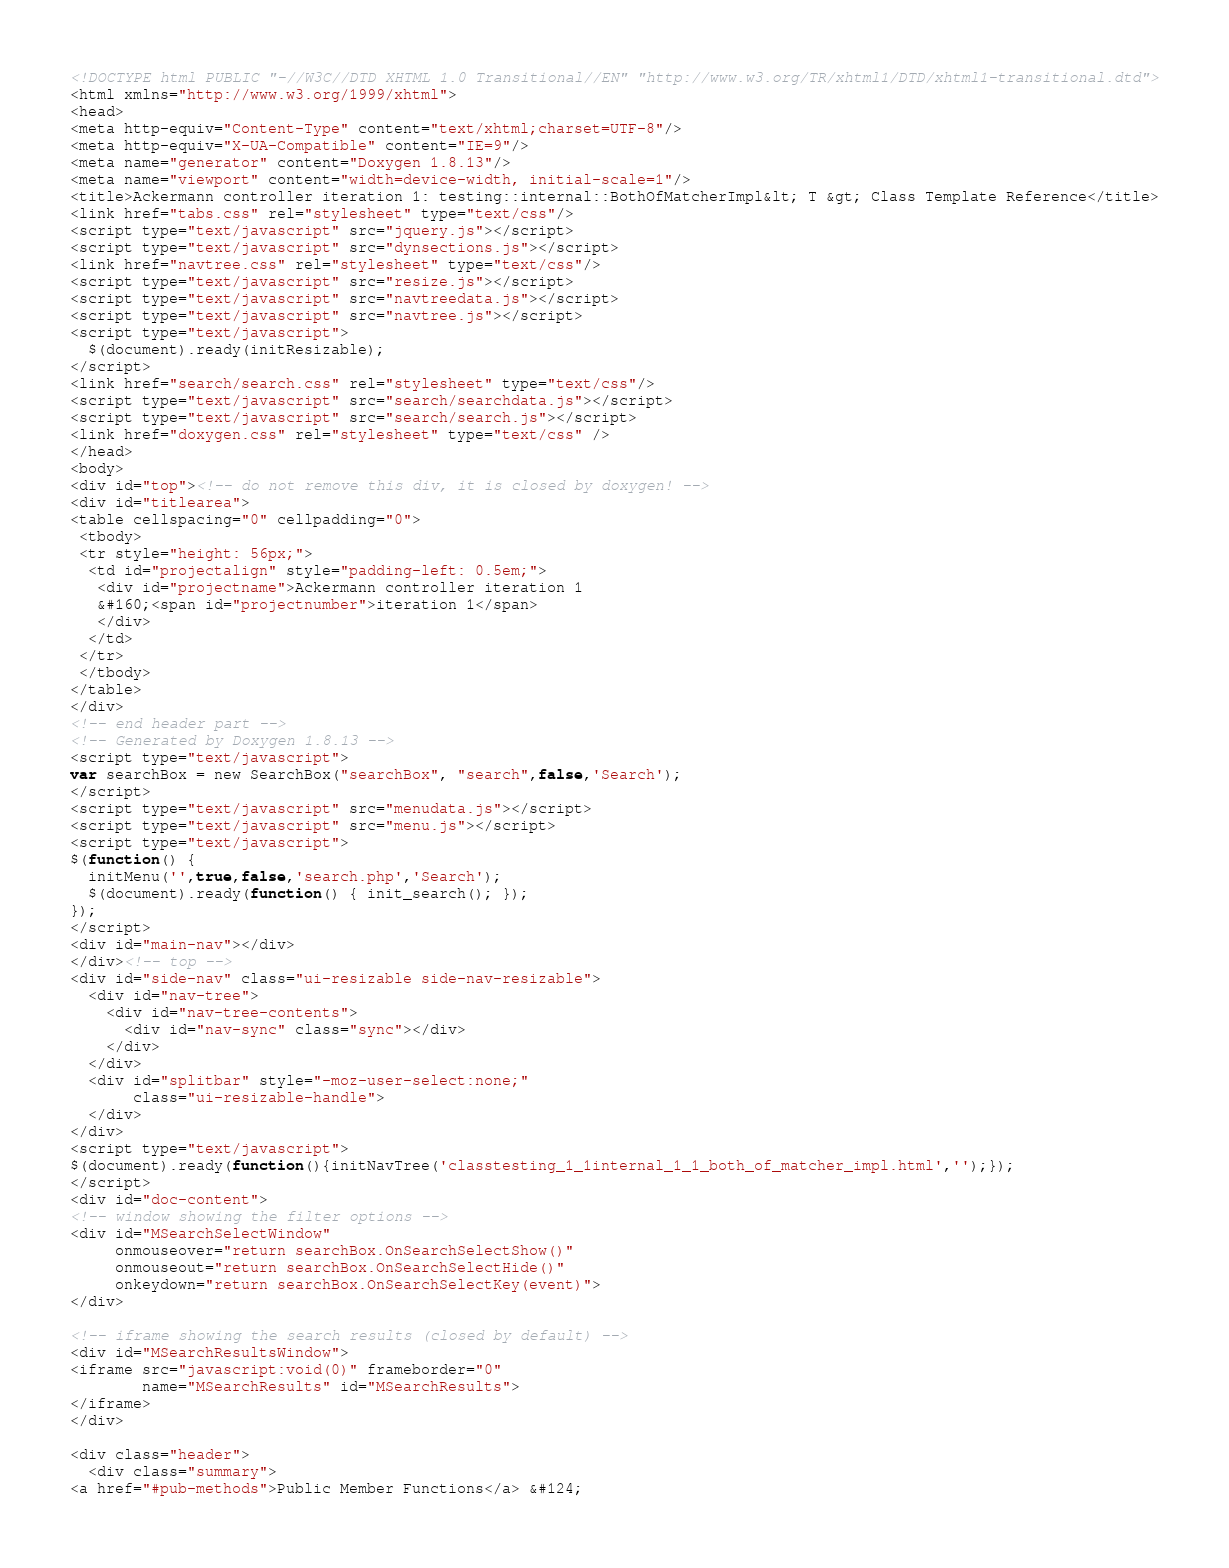Convert code to text. <code><loc_0><loc_0><loc_500><loc_500><_HTML_><!DOCTYPE html PUBLIC "-//W3C//DTD XHTML 1.0 Transitional//EN" "http://www.w3.org/TR/xhtml1/DTD/xhtml1-transitional.dtd">
<html xmlns="http://www.w3.org/1999/xhtml">
<head>
<meta http-equiv="Content-Type" content="text/xhtml;charset=UTF-8"/>
<meta http-equiv="X-UA-Compatible" content="IE=9"/>
<meta name="generator" content="Doxygen 1.8.13"/>
<meta name="viewport" content="width=device-width, initial-scale=1"/>
<title>Ackermann controller iteration 1: testing::internal::BothOfMatcherImpl&lt; T &gt; Class Template Reference</title>
<link href="tabs.css" rel="stylesheet" type="text/css"/>
<script type="text/javascript" src="jquery.js"></script>
<script type="text/javascript" src="dynsections.js"></script>
<link href="navtree.css" rel="stylesheet" type="text/css"/>
<script type="text/javascript" src="resize.js"></script>
<script type="text/javascript" src="navtreedata.js"></script>
<script type="text/javascript" src="navtree.js"></script>
<script type="text/javascript">
  $(document).ready(initResizable);
</script>
<link href="search/search.css" rel="stylesheet" type="text/css"/>
<script type="text/javascript" src="search/searchdata.js"></script>
<script type="text/javascript" src="search/search.js"></script>
<link href="doxygen.css" rel="stylesheet" type="text/css" />
</head>
<body>
<div id="top"><!-- do not remove this div, it is closed by doxygen! -->
<div id="titlearea">
<table cellspacing="0" cellpadding="0">
 <tbody>
 <tr style="height: 56px;">
  <td id="projectalign" style="padding-left: 0.5em;">
   <div id="projectname">Ackermann controller iteration 1
   &#160;<span id="projectnumber">iteration 1</span>
   </div>
  </td>
 </tr>
 </tbody>
</table>
</div>
<!-- end header part -->
<!-- Generated by Doxygen 1.8.13 -->
<script type="text/javascript">
var searchBox = new SearchBox("searchBox", "search",false,'Search');
</script>
<script type="text/javascript" src="menudata.js"></script>
<script type="text/javascript" src="menu.js"></script>
<script type="text/javascript">
$(function() {
  initMenu('',true,false,'search.php','Search');
  $(document).ready(function() { init_search(); });
});
</script>
<div id="main-nav"></div>
</div><!-- top -->
<div id="side-nav" class="ui-resizable side-nav-resizable">
  <div id="nav-tree">
    <div id="nav-tree-contents">
      <div id="nav-sync" class="sync"></div>
    </div>
  </div>
  <div id="splitbar" style="-moz-user-select:none;" 
       class="ui-resizable-handle">
  </div>
</div>
<script type="text/javascript">
$(document).ready(function(){initNavTree('classtesting_1_1internal_1_1_both_of_matcher_impl.html','');});
</script>
<div id="doc-content">
<!-- window showing the filter options -->
<div id="MSearchSelectWindow"
     onmouseover="return searchBox.OnSearchSelectShow()"
     onmouseout="return searchBox.OnSearchSelectHide()"
     onkeydown="return searchBox.OnSearchSelectKey(event)">
</div>

<!-- iframe showing the search results (closed by default) -->
<div id="MSearchResultsWindow">
<iframe src="javascript:void(0)" frameborder="0" 
        name="MSearchResults" id="MSearchResults">
</iframe>
</div>

<div class="header">
  <div class="summary">
<a href="#pub-methods">Public Member Functions</a> &#124;</code> 